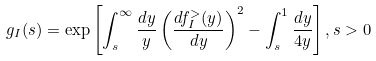Convert formula to latex. <formula><loc_0><loc_0><loc_500><loc_500>g _ { I } ( s ) = \exp \left [ \int _ { s } ^ { \infty } \frac { d y } { y } \left ( \frac { d f _ { I } ^ { > } ( y ) } { d y } \right ) ^ { 2 } - \int _ { s } ^ { 1 } \frac { d y } { 4 y } \right ] , s > 0</formula> 